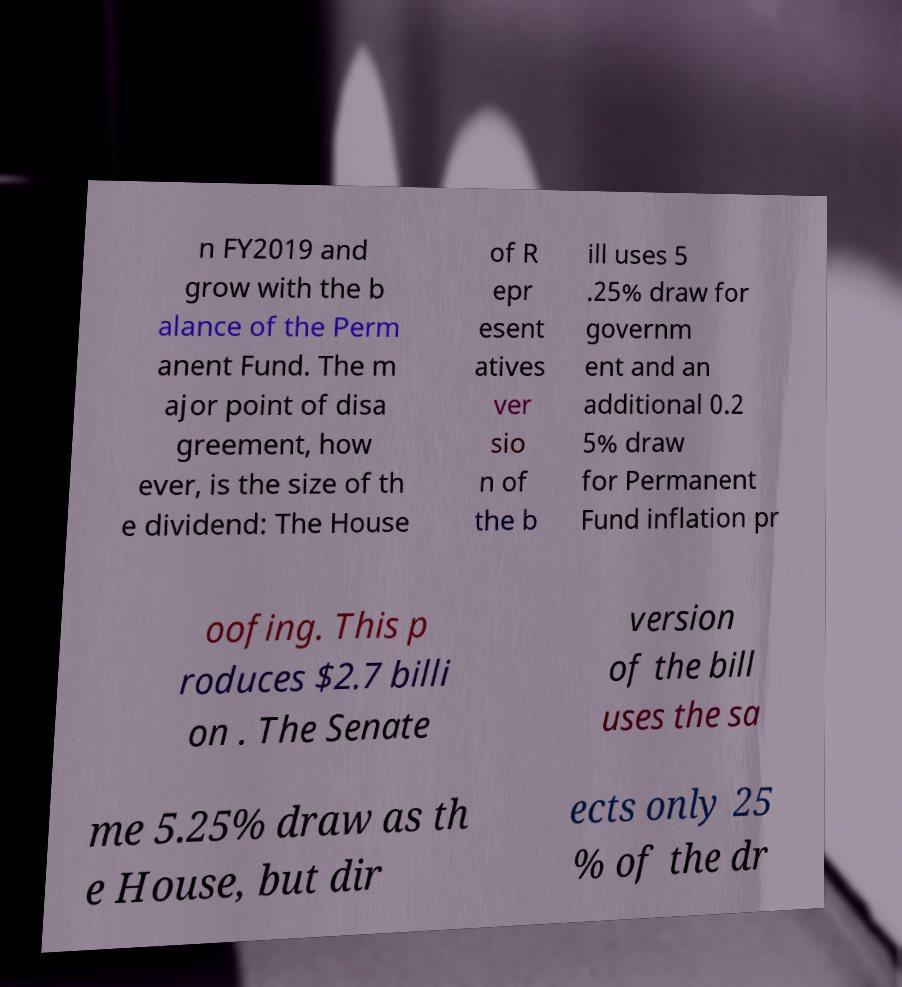Can you accurately transcribe the text from the provided image for me? n FY2019 and grow with the b alance of the Perm anent Fund. The m ajor point of disa greement, how ever, is the size of th e dividend: The House of R epr esent atives ver sio n of the b ill uses 5 .25% draw for governm ent and an additional 0.2 5% draw for Permanent Fund inflation pr oofing. This p roduces $2.7 billi on . The Senate version of the bill uses the sa me 5.25% draw as th e House, but dir ects only 25 % of the dr 